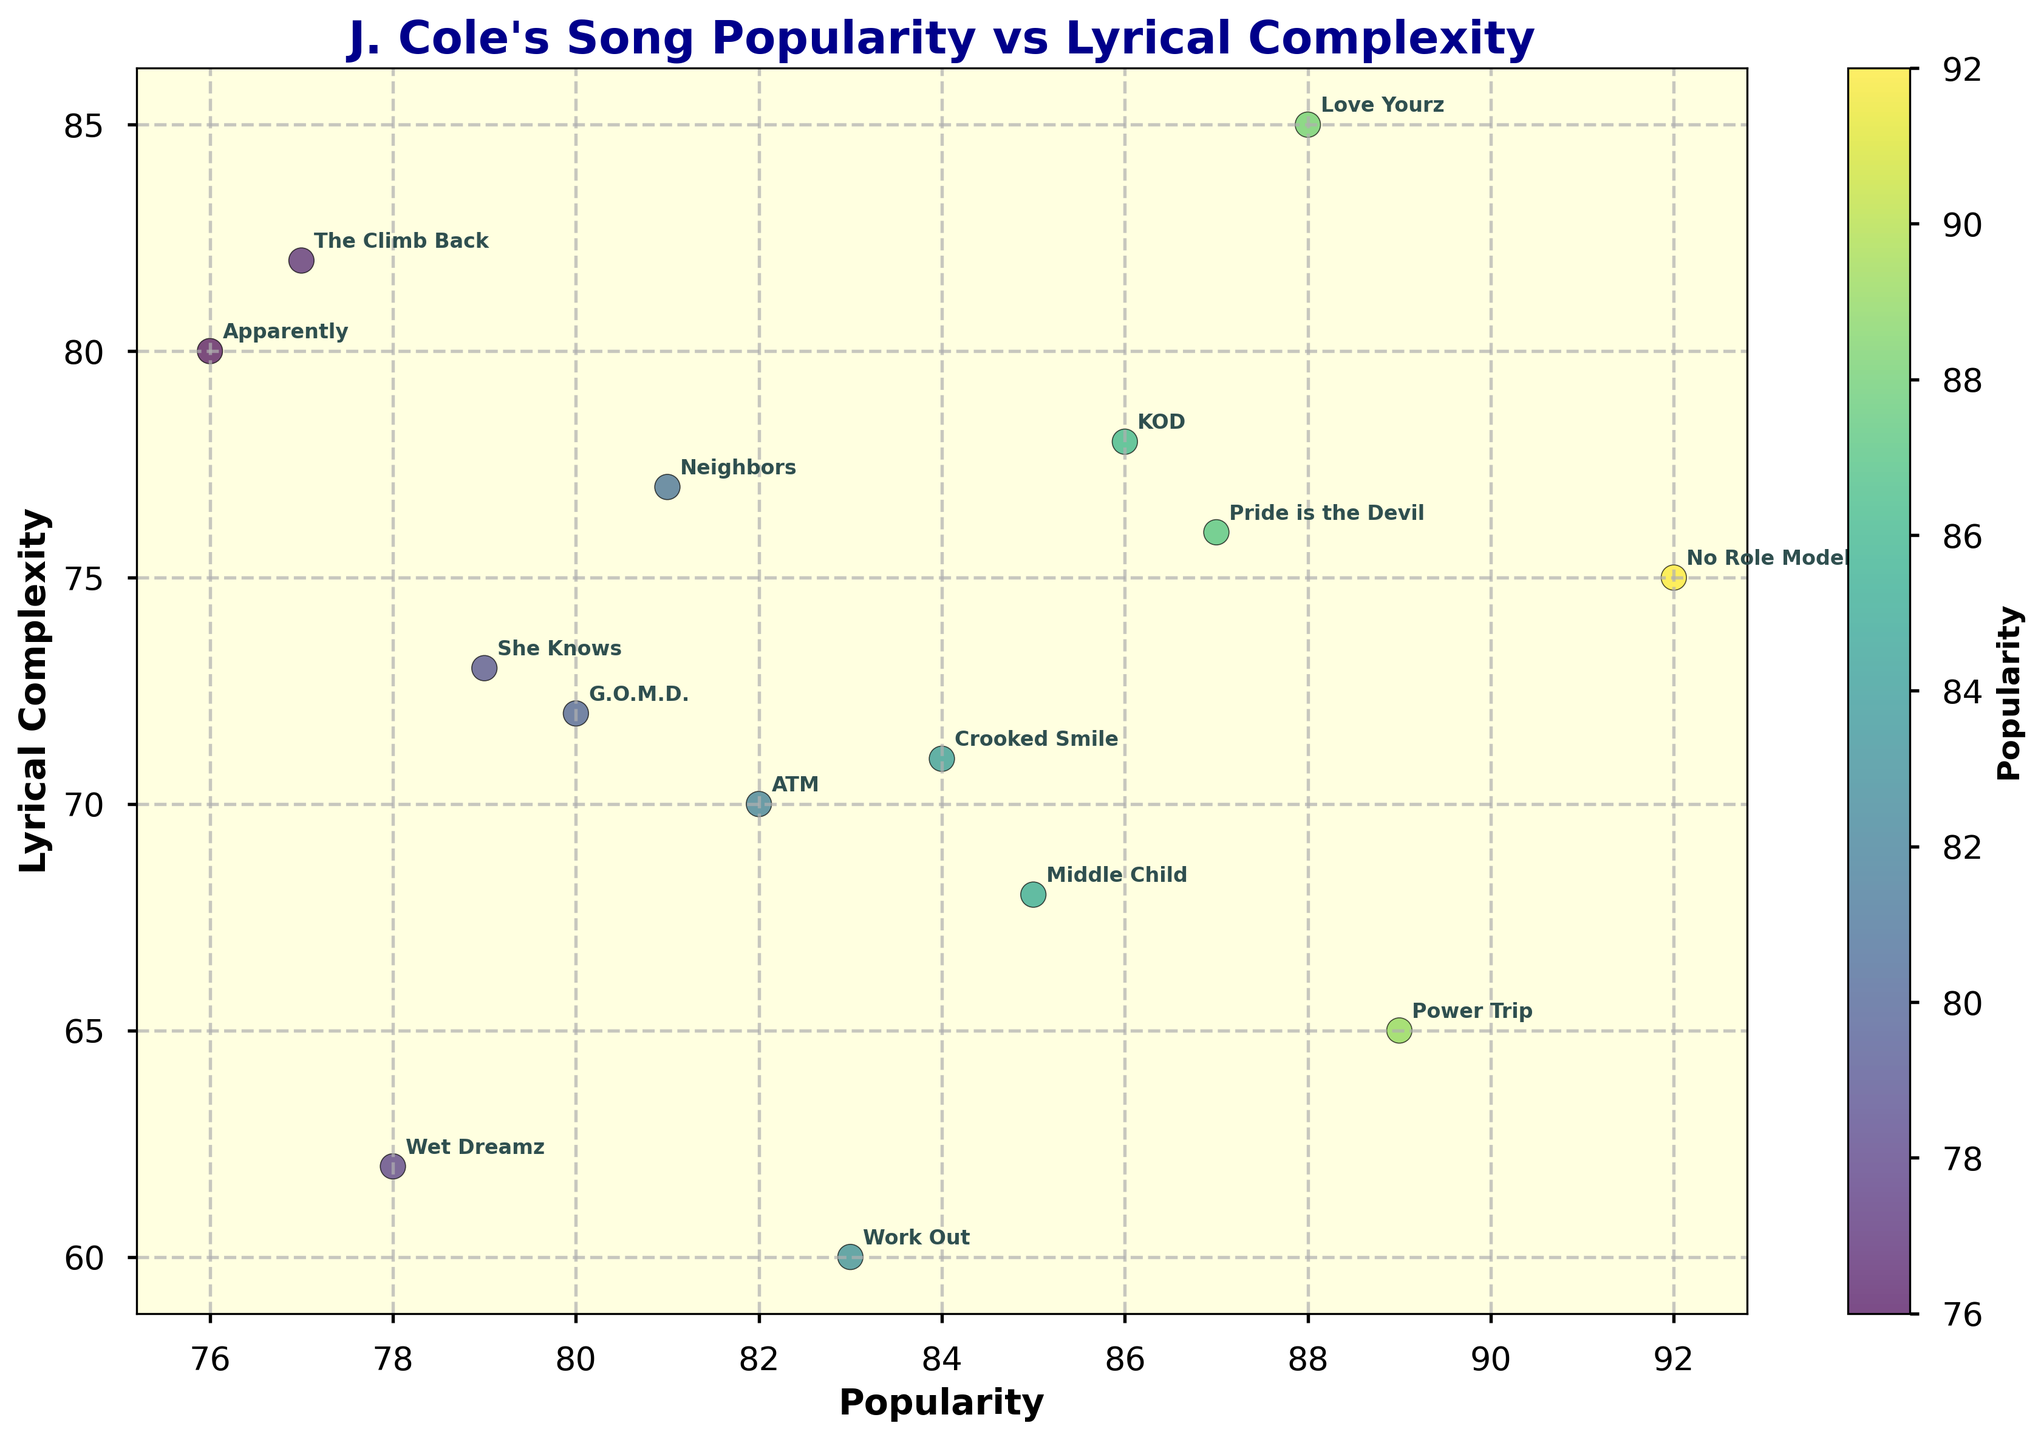What are the axes of the plot? The plot has two labeled axes. The x-axis represents "Popularity," and the y-axis represents "Lyrical Complexity."
Answer: Popularity and Lyrical Complexity Which song has the highest popularity score? The plot shows data points representing songs with their popularity and lyrical complexity. The song with the highest data point on the x-axis is "No Role Modelz" with a popularity score of 92.
Answer: No Role Modelz Which song has the highest lyrical complexity? The plot represents songs with their popularity and lyrical complexity. The song with the highest data point on the y-axis is "Love Yourz" with a lyrical complexity score of 85.
Answer: Love Yourz What is the average lyrical complexity score of all the songs? To find the average, sum all the lyrical complexity scores and divide by the number of songs. The scores are 68, 75, 62, 85, 72, 70, 78, 80, 73, 60, 76, 77, 82, 71, and 65. Summing these gives 1016. Dividing by 15 gives approximately 67.
Answer: 67.7 Do any two songs have the same popularity score? By looking at the x-coordinates of each data point, it is evident that no two songs share the same popularity score; each x-coordinate is unique.
Answer: No Which song has both high popularity and high lyrical complexity? By analyzing the data points located toward the upper-right side of the plot (high on both axes), "Love Yourz" stands out with both a high popularity score of 88 and a high lyrical complexity score of 85.
Answer: Love Yourz Is there a positive correlation between popularity and lyrical complexity? By examining the trend of the data points, there appears to be an upward trend or positive correlation, meaning as popularity increases, lyrical complexity also tends to increase.
Answer: Yes Which song has the greatest difference between popularity and lyrical complexity? To find the greatest difference, subtract the lyrical complexity score from the popularity score for each song and identify the maximum difference. For example, for "Power Trip," the difference is 24 (89 - 65), which is the highest difference among the songs.
Answer: Power Trip How many songs have lyrical complexity above 75? By counting the data points above the 75 mark on the y-axis, there are six songs: "Love Yourz," "Apparently," "Pride is the Devil," "Neighbors," "The Climb Back," and "No Role Modelz."
Answer: 6 Which song has the lowest popularity and what is its lyrical complexity? The song with the lowest data point on the x-axis is "Apparently" with a popularity score of 76. Its lyrical complexity is 80.
Answer: Apparently, 80 